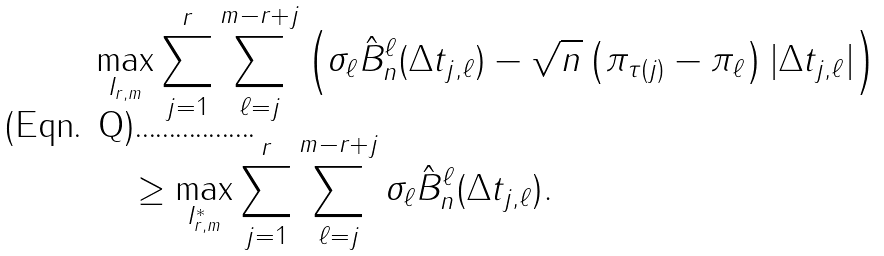Convert formula to latex. <formula><loc_0><loc_0><loc_500><loc_500>& \max _ { I _ { r , m } } \sum _ { j = 1 } ^ { r } \sum _ { \ell = j } ^ { m - r + j } \left ( \sigma _ { \ell } \hat { B } _ { n } ^ { \ell } ( \Delta t _ { j , \ell } ) - \sqrt { n } \left ( \pi _ { \tau ( j ) } - \pi _ { \ell } \right ) | \Delta t _ { j , \ell } | \right ) \\ & \quad \geq \max _ { I _ { r , m } ^ { * } } \sum _ { j = 1 } ^ { r } \sum _ { \ell = j } ^ { m - r + j } \sigma _ { \ell } \hat { B } _ { n } ^ { \ell } ( \Delta t _ { j , \ell } ) .</formula> 